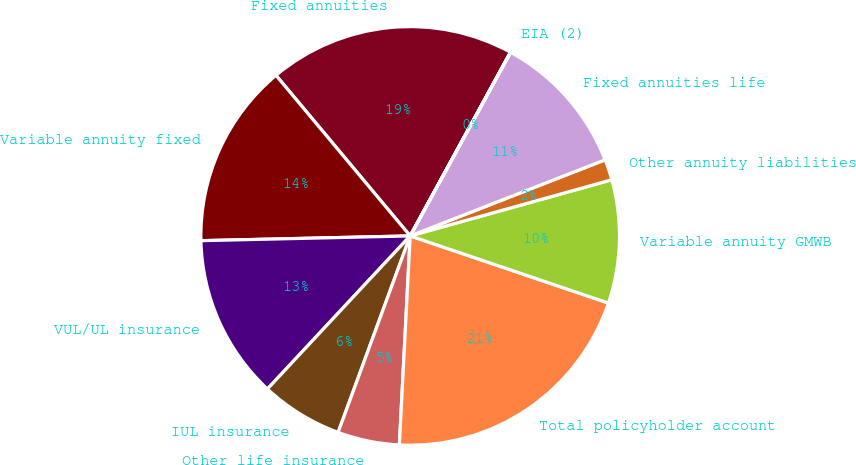Convert chart. <chart><loc_0><loc_0><loc_500><loc_500><pie_chart><fcel>Fixed annuities<fcel>Variable annuity fixed<fcel>VUL/UL insurance<fcel>IUL insurance<fcel>Other life insurance<fcel>Total policyholder account<fcel>Variable annuity GMWB<fcel>Other annuity liabilities<fcel>Fixed annuities life<fcel>EIA (2)<nl><fcel>19.03%<fcel>14.28%<fcel>12.69%<fcel>6.35%<fcel>4.77%<fcel>20.62%<fcel>9.52%<fcel>1.6%<fcel>11.11%<fcel>0.01%<nl></chart> 